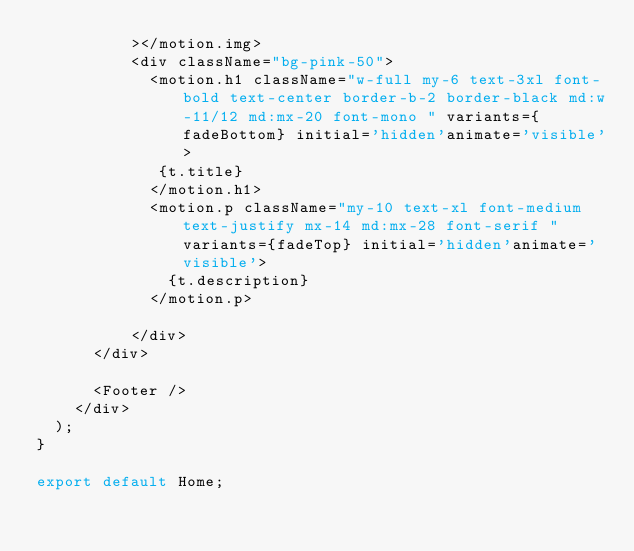<code> <loc_0><loc_0><loc_500><loc_500><_TypeScript_>          ></motion.img>
          <div className="bg-pink-50">
            <motion.h1 className="w-full my-6 text-3xl font-bold text-center border-b-2 border-black md:w-11/12 md:mx-20 font-mono " variants={fadeBottom} initial='hidden'animate='visible'>
             {t.title}
            </motion.h1>
            <motion.p className="my-10 text-xl font-medium text-justify mx-14 md:mx-28 font-serif " variants={fadeTop} initial='hidden'animate='visible'>
              {t.description}
            </motion.p>
    
          </div>
      </div>

      <Footer />
    </div>
  );
}

export default Home;</code> 